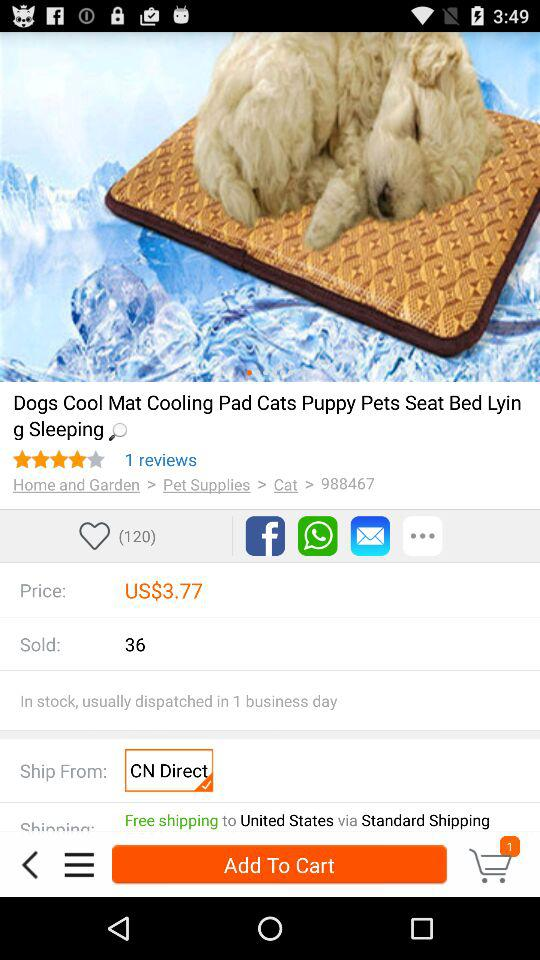Who is buying the dog cooling mat?
When the provided information is insufficient, respond with <no answer>. <no answer> 